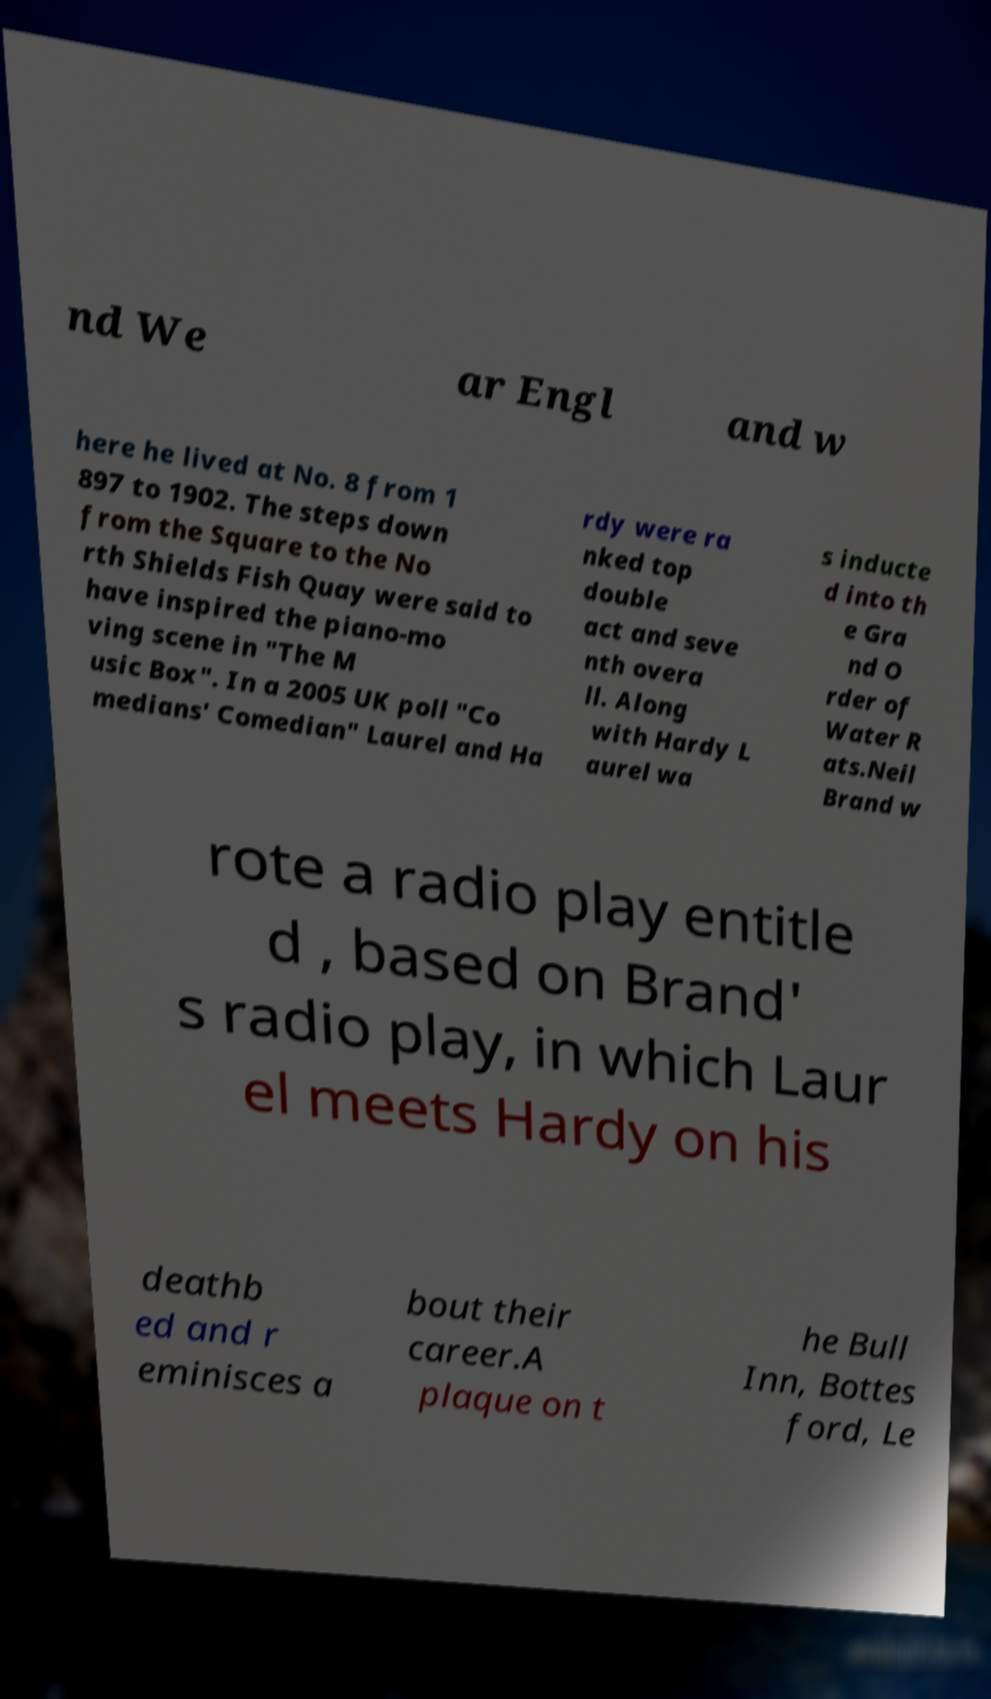Can you accurately transcribe the text from the provided image for me? nd We ar Engl and w here he lived at No. 8 from 1 897 to 1902. The steps down from the Square to the No rth Shields Fish Quay were said to have inspired the piano-mo ving scene in "The M usic Box". In a 2005 UK poll "Co medians' Comedian" Laurel and Ha rdy were ra nked top double act and seve nth overa ll. Along with Hardy L aurel wa s inducte d into th e Gra nd O rder of Water R ats.Neil Brand w rote a radio play entitle d , based on Brand' s radio play, in which Laur el meets Hardy on his deathb ed and r eminisces a bout their career.A plaque on t he Bull Inn, Bottes ford, Le 